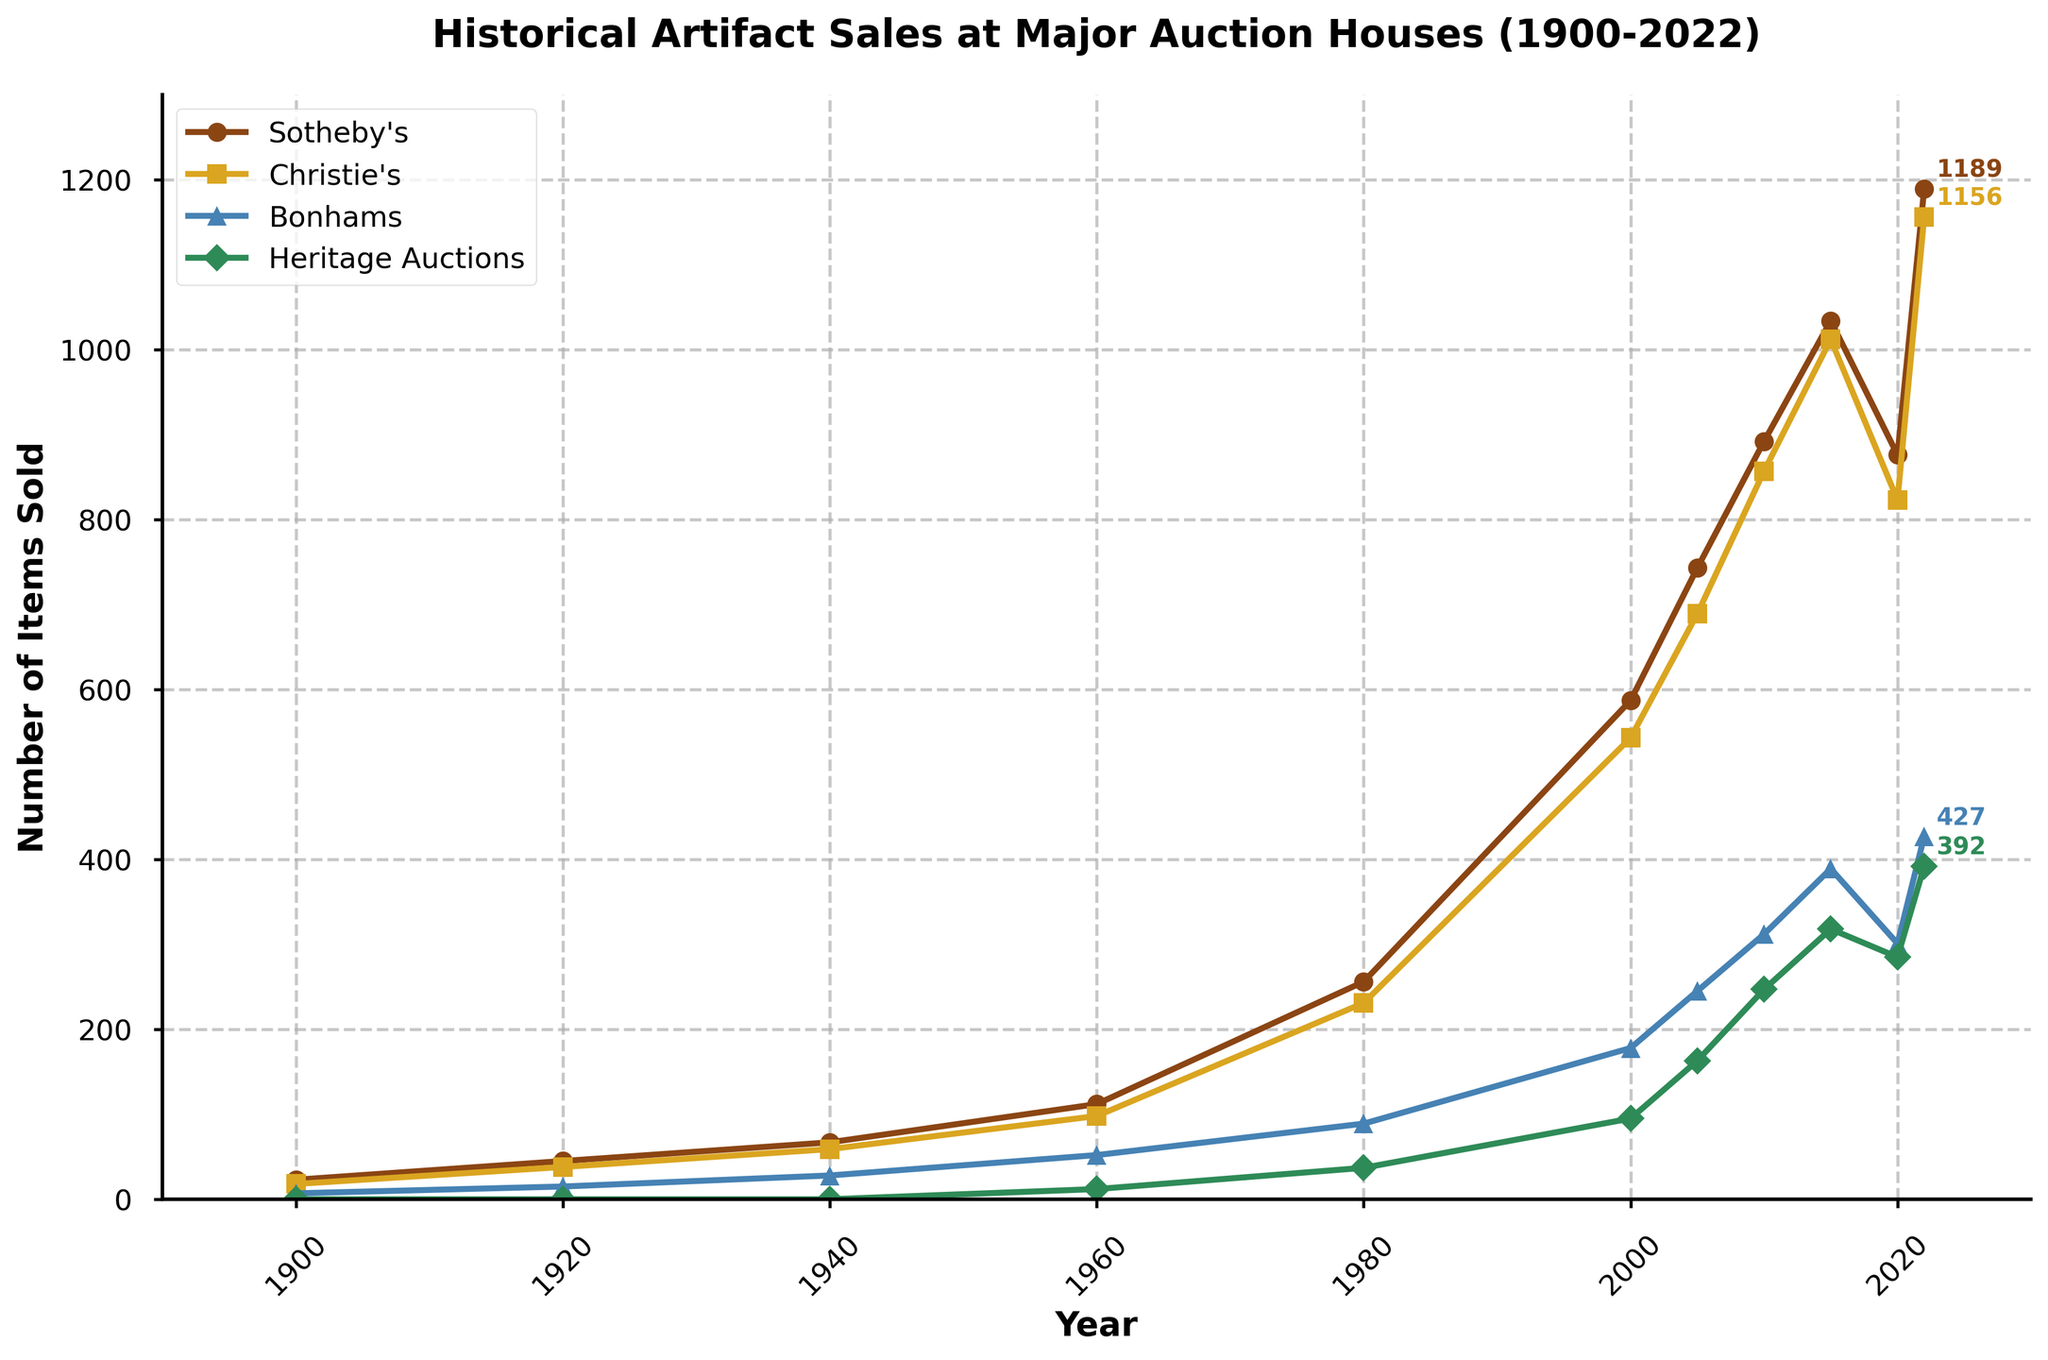Which auction house sold the most historical artifacts in 2022? The line representing Sotheby's reaches the highest point in 2022, indicating the largest number of items sold. Sotheby's sold 1189 items.
Answer: Sotheby's Which auction house showed the most consistent increase in sales from 1900 to 2022? By observing the trend lines, Christie's shows a steady increase with fewer fluctuations compared to others. The increase is consistent till 2022.
Answer: Christie's How did the number of items sold by Heritage Auctions change between 1960 and 2000? In 1960, Heritage Auctions sold 12 items, and by 2000, the sales increased to 95 items. The number increased by observing the points on the line plot.
Answer: Increased Which auction house experienced a decrease in the number of items sold from 2015 to 2020? By tracking the points from 2015 to 2020, Sotheby's shows a decrease in sales from 1034 to 876 items.
Answer: Sotheby's Which two auction houses had nearly identical sales numbers in 2020? Examining the 2020 data points, Sotheby's (876) and Christie's (823) had quite close figures.
Answer: Sotheby's and Christie's What is the average number of items sold by Bonhams in 1920 and 1940? Bonhams sold 15 items in 1920 and 28 items in 1940. The average is calculated as (15 + 28) / 2 = 21.5.
Answer: 21.5 In which year did Christie's first surpass 500 items sold in a year? Following the Christie's line plot, the first point surpassing 500 items is in 2000 with 543 items sold.
Answer: 2000 From 1900 to 2022, which auction house shows the highest overall growth in sales numbers? Assessing the elevation in data points from 1900 to 2022, Sotheby's shows the greatest increase from 23 to 1189 items.
Answer: Sotheby's Compare the sales trends of Heritage Auctions and Bonhams from 2000 to 2015. Which house saw larger growth? Heritage Auctions increased from 95 in 2000 to 318 in 2015, an increase of 223 items. Bonhams grew from 178 to 389, an increase of 211 items. Heritage Auctions had larger growth.
Answer: Heritage Auctions What is the difference in the number of items sold by Sotheby's between 1920 and 1980? Sotheby's sold 45 items in 1920 and 256 items in 1980. The difference is 256 - 45 = 211.
Answer: 211 